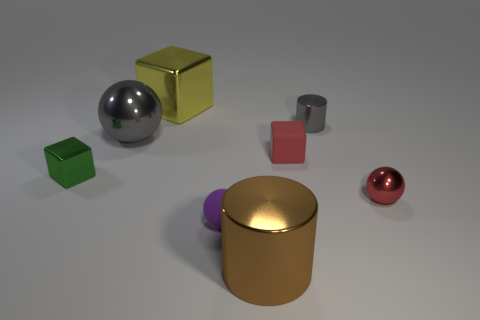Add 1 spheres. How many objects exist? 9 Subtract all metal spheres. How many spheres are left? 1 Subtract 1 cubes. How many cubes are left? 2 Subtract all red blocks. How many blocks are left? 2 Subtract all cylinders. How many objects are left? 6 Subtract all small matte things. Subtract all large shiny objects. How many objects are left? 3 Add 6 large brown shiny cylinders. How many large brown shiny cylinders are left? 7 Add 1 big brown things. How many big brown things exist? 2 Subtract 0 brown spheres. How many objects are left? 8 Subtract all brown blocks. Subtract all brown cylinders. How many blocks are left? 3 